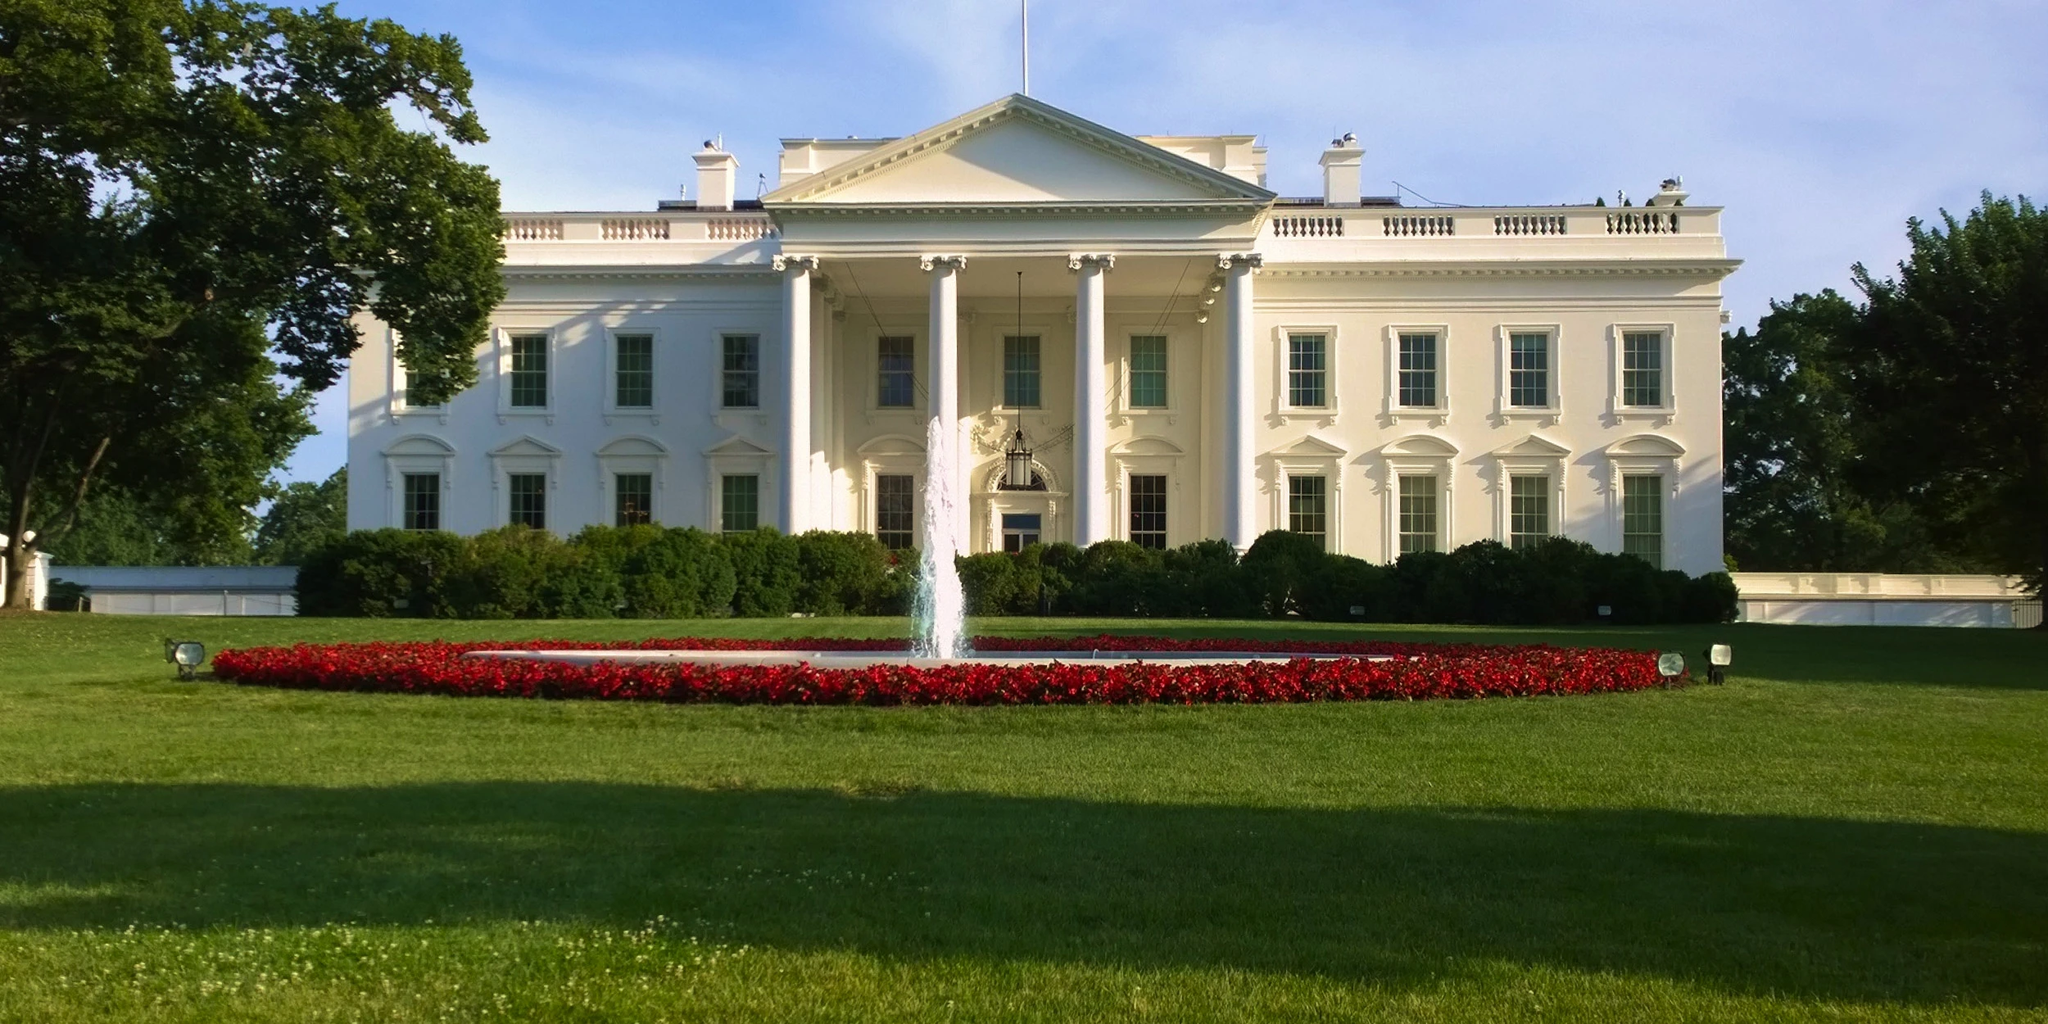How does the landscaping around the White House enhance its overall appearance? The landscaping around the White House is meticulously designed to complement the grandeur and elegance of the building itself. The expansive lawns, well-trimmed hedges, and carefully curated flower beds create a picturesque setting that enhances the visual appeal of the White House. The vibrant greenery and colorful flowers add a touch of natural beauty, providing a serene backdrop for the official residence. This careful landscaping also serves a practical purpose, enhancing security and providing a space for outdoor events and ceremonies. 